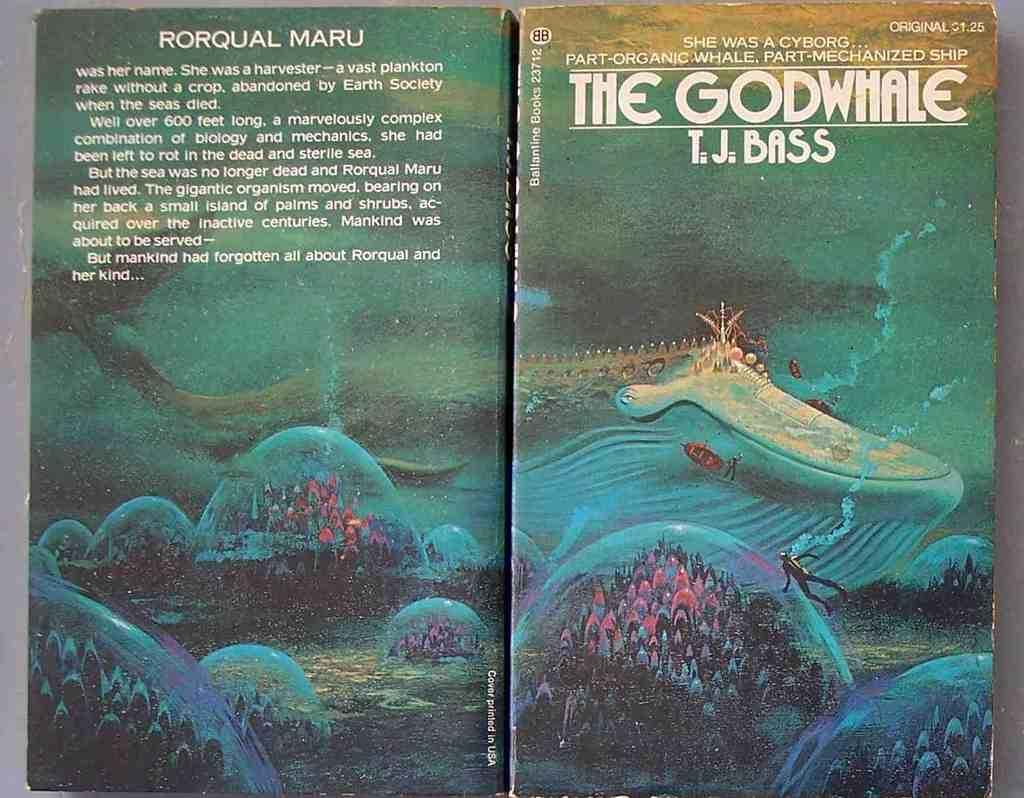Provide a one-sentence caption for the provided image. A picture of a book title The Godwhale by T.J. Bass. 